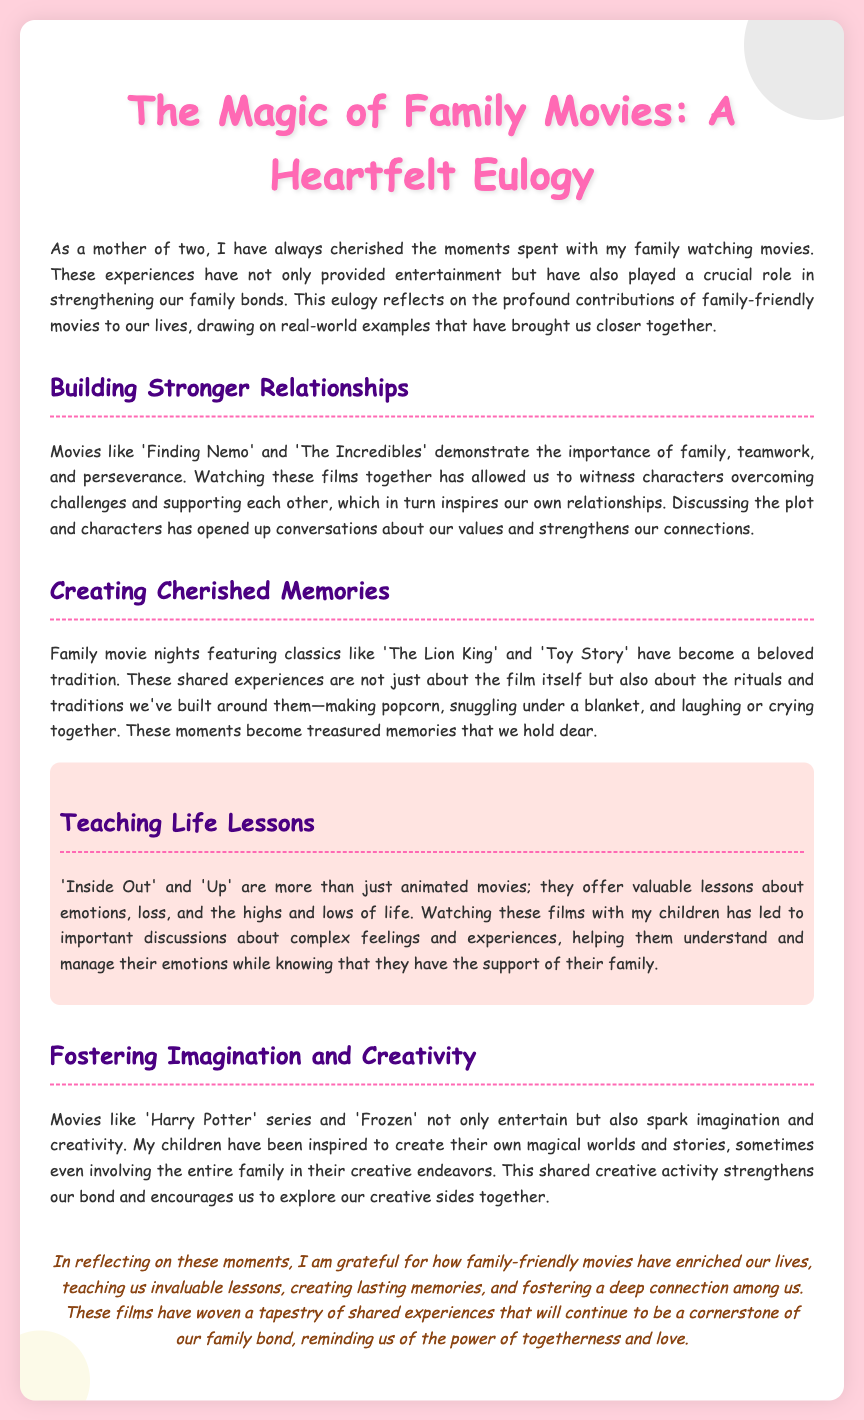What are two movies mentioned that build stronger relationships? The document lists 'Finding Nemo' and 'The Incredibles' as movies that demonstrate the importance of family and teamwork.
Answer: 'Finding Nemo', 'The Incredibles' What is a beloved family movie night tradition mentioned? The document describes that family movie nights include making popcorn, snuggling under blankets, and laughing or crying together.
Answer: Making popcorn Which animated movies are highlighted for teaching life lessons? The eulogy specifically mentions 'Inside Out' and 'Up' as being more than just animated movies; they offer valuable lessons.
Answer: 'Inside Out', 'Up' What do movies like 'Harry Potter' and 'Frozen' inspire children to do? According to the document, these movies inspire children to create their own magical worlds and stories.
Answer: Create their own magical worlds What key themes are reflected in family-friendly movies according to the eulogy? The document discusses themes of emotions, loss, creativity, and family support as it relates to the films watched together.
Answer: Emotions, loss, creativity, family support What is a significant effect of family movies on family bonding? The eulogy notes that family-friendly movies create lasting memories and foster deep connections among family members.
Answer: Lasting memories, deep connections 